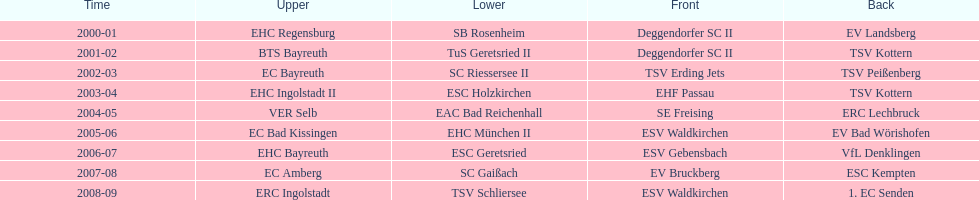The only team to win the north in 2000-01 season? EHC Regensburg. 